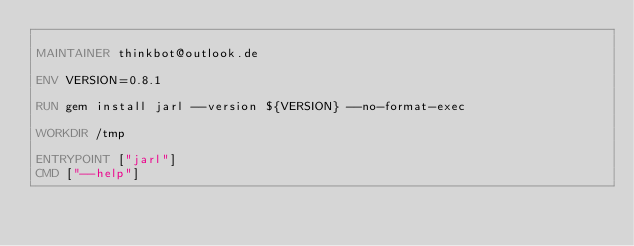Convert code to text. <code><loc_0><loc_0><loc_500><loc_500><_Dockerfile_>
MAINTAINER thinkbot@outlook.de

ENV VERSION=0.8.1

RUN gem install jarl --version ${VERSION} --no-format-exec

WORKDIR /tmp

ENTRYPOINT ["jarl"]
CMD ["--help"]
</code> 